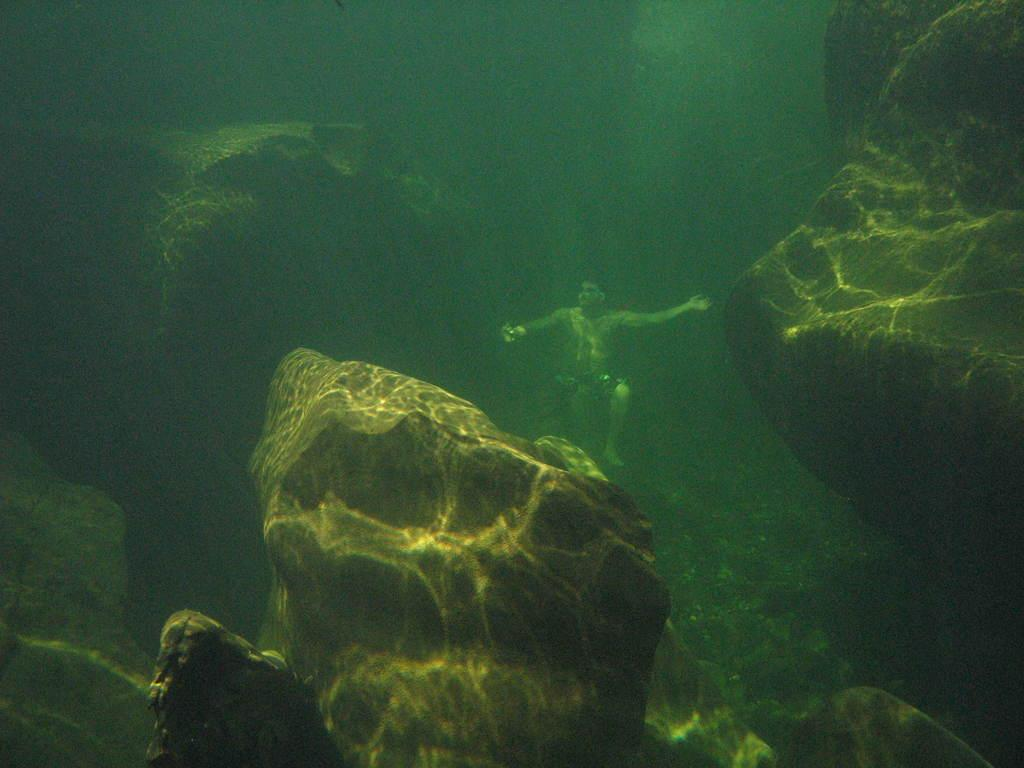What is present in the image? There is a person in the image. Can you describe the environment in the image? There are rocks in the water in the image. What type of cart is being used to transport the sweater in the image? There is no cart or sweater present in the image. 